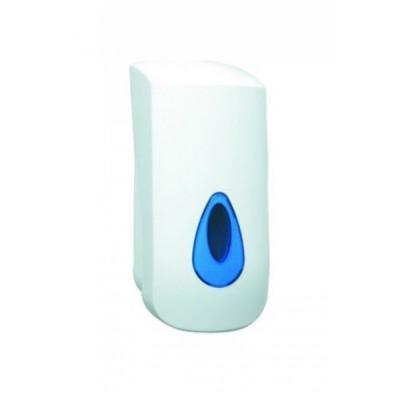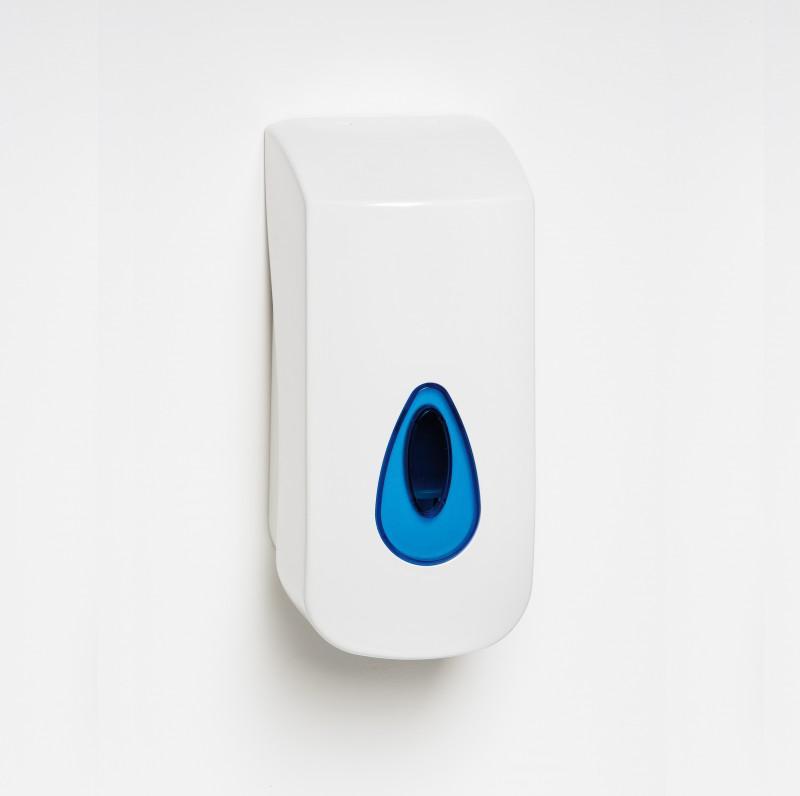The first image is the image on the left, the second image is the image on the right. Given the left and right images, does the statement "One image shows a dispenser sitting on a wood-grain surface." hold true? Answer yes or no. No. The first image is the image on the left, the second image is the image on the right. Examine the images to the left and right. Is the description "The dispenser in the image on the right is sitting on wood." accurate? Answer yes or no. No. 